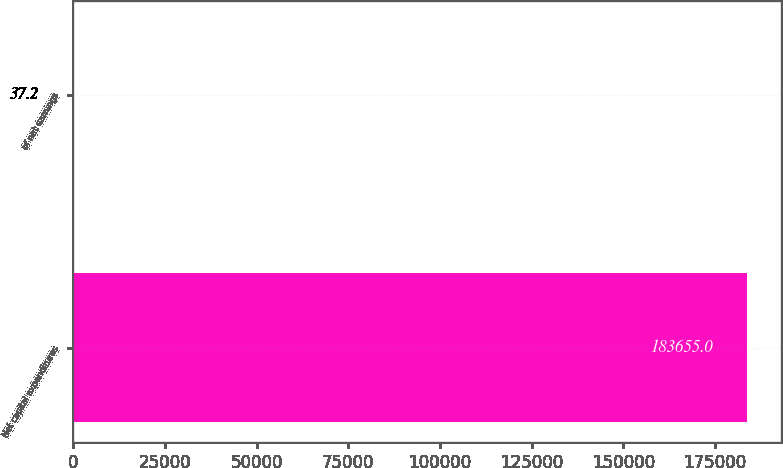Convert chart to OTSL. <chart><loc_0><loc_0><loc_500><loc_500><bar_chart><fcel>Net capital expenditures<fcel>of net earnings<nl><fcel>183655<fcel>37.2<nl></chart> 